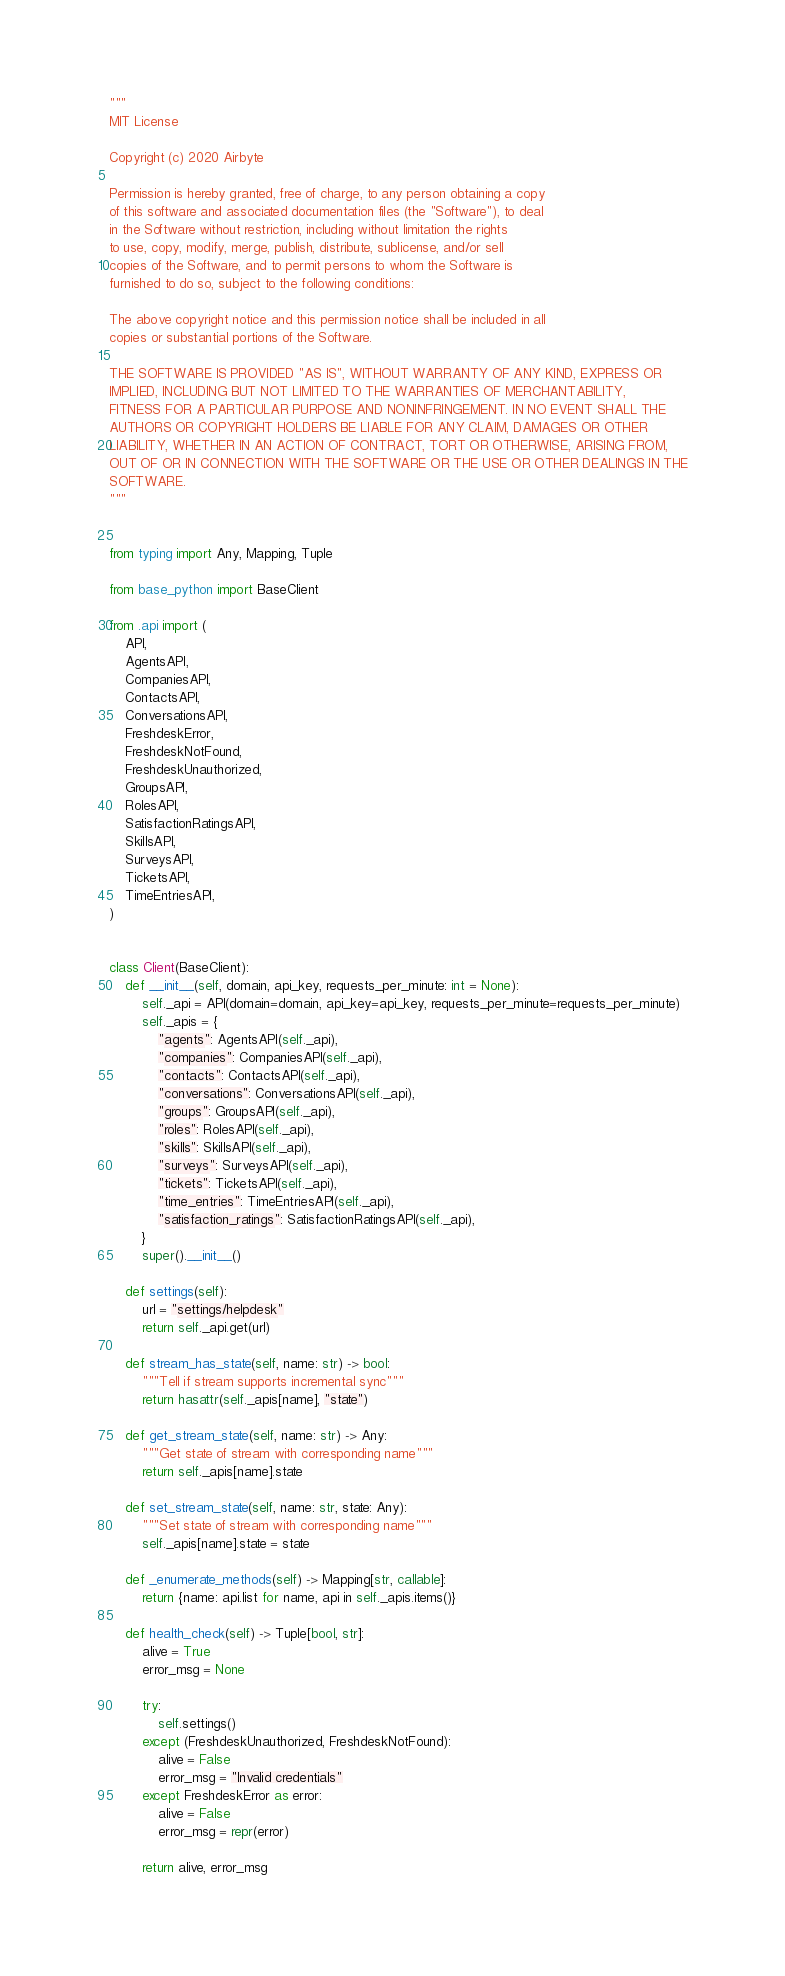<code> <loc_0><loc_0><loc_500><loc_500><_Python_>"""
MIT License

Copyright (c) 2020 Airbyte

Permission is hereby granted, free of charge, to any person obtaining a copy
of this software and associated documentation files (the "Software"), to deal
in the Software without restriction, including without limitation the rights
to use, copy, modify, merge, publish, distribute, sublicense, and/or sell
copies of the Software, and to permit persons to whom the Software is
furnished to do so, subject to the following conditions:

The above copyright notice and this permission notice shall be included in all
copies or substantial portions of the Software.

THE SOFTWARE IS PROVIDED "AS IS", WITHOUT WARRANTY OF ANY KIND, EXPRESS OR
IMPLIED, INCLUDING BUT NOT LIMITED TO THE WARRANTIES OF MERCHANTABILITY,
FITNESS FOR A PARTICULAR PURPOSE AND NONINFRINGEMENT. IN NO EVENT SHALL THE
AUTHORS OR COPYRIGHT HOLDERS BE LIABLE FOR ANY CLAIM, DAMAGES OR OTHER
LIABILITY, WHETHER IN AN ACTION OF CONTRACT, TORT OR OTHERWISE, ARISING FROM,
OUT OF OR IN CONNECTION WITH THE SOFTWARE OR THE USE OR OTHER DEALINGS IN THE
SOFTWARE.
"""


from typing import Any, Mapping, Tuple

from base_python import BaseClient

from .api import (
    API,
    AgentsAPI,
    CompaniesAPI,
    ContactsAPI,
    ConversationsAPI,
    FreshdeskError,
    FreshdeskNotFound,
    FreshdeskUnauthorized,
    GroupsAPI,
    RolesAPI,
    SatisfactionRatingsAPI,
    SkillsAPI,
    SurveysAPI,
    TicketsAPI,
    TimeEntriesAPI,
)


class Client(BaseClient):
    def __init__(self, domain, api_key, requests_per_minute: int = None):
        self._api = API(domain=domain, api_key=api_key, requests_per_minute=requests_per_minute)
        self._apis = {
            "agents": AgentsAPI(self._api),
            "companies": CompaniesAPI(self._api),
            "contacts": ContactsAPI(self._api),
            "conversations": ConversationsAPI(self._api),
            "groups": GroupsAPI(self._api),
            "roles": RolesAPI(self._api),
            "skills": SkillsAPI(self._api),
            "surveys": SurveysAPI(self._api),
            "tickets": TicketsAPI(self._api),
            "time_entries": TimeEntriesAPI(self._api),
            "satisfaction_ratings": SatisfactionRatingsAPI(self._api),
        }
        super().__init__()

    def settings(self):
        url = "settings/helpdesk"
        return self._api.get(url)

    def stream_has_state(self, name: str) -> bool:
        """Tell if stream supports incremental sync"""
        return hasattr(self._apis[name], "state")

    def get_stream_state(self, name: str) -> Any:
        """Get state of stream with corresponding name"""
        return self._apis[name].state

    def set_stream_state(self, name: str, state: Any):
        """Set state of stream with corresponding name"""
        self._apis[name].state = state

    def _enumerate_methods(self) -> Mapping[str, callable]:
        return {name: api.list for name, api in self._apis.items()}

    def health_check(self) -> Tuple[bool, str]:
        alive = True
        error_msg = None

        try:
            self.settings()
        except (FreshdeskUnauthorized, FreshdeskNotFound):
            alive = False
            error_msg = "Invalid credentials"
        except FreshdeskError as error:
            alive = False
            error_msg = repr(error)

        return alive, error_msg
</code> 